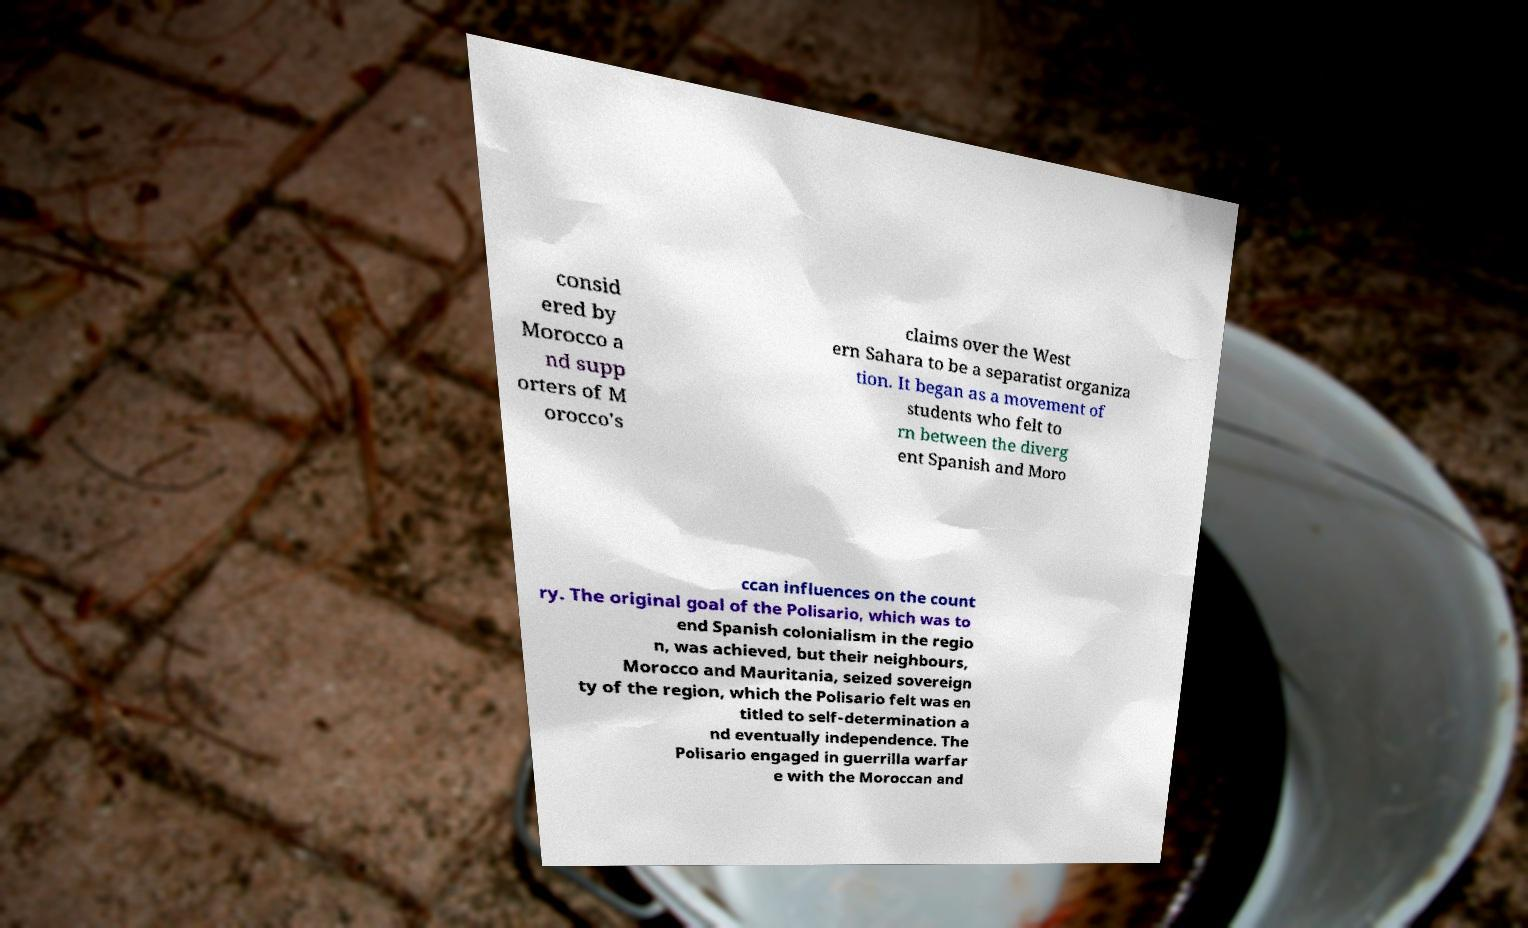I need the written content from this picture converted into text. Can you do that? consid ered by Morocco a nd supp orters of M orocco's claims over the West ern Sahara to be a separatist organiza tion. It began as a movement of students who felt to rn between the diverg ent Spanish and Moro ccan influences on the count ry. The original goal of the Polisario, which was to end Spanish colonialism in the regio n, was achieved, but their neighbours, Morocco and Mauritania, seized sovereign ty of the region, which the Polisario felt was en titled to self-determination a nd eventually independence. The Polisario engaged in guerrilla warfar e with the Moroccan and 